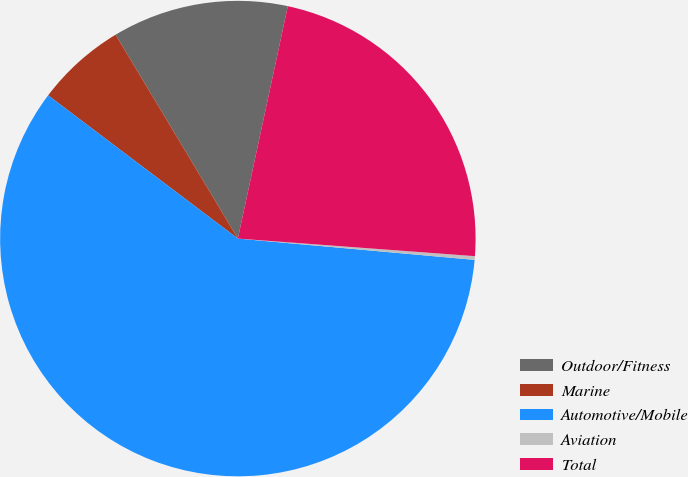<chart> <loc_0><loc_0><loc_500><loc_500><pie_chart><fcel>Outdoor/Fitness<fcel>Marine<fcel>Automotive/Mobile<fcel>Aviation<fcel>Total<nl><fcel>11.97%<fcel>6.11%<fcel>58.87%<fcel>0.25%<fcel>22.81%<nl></chart> 